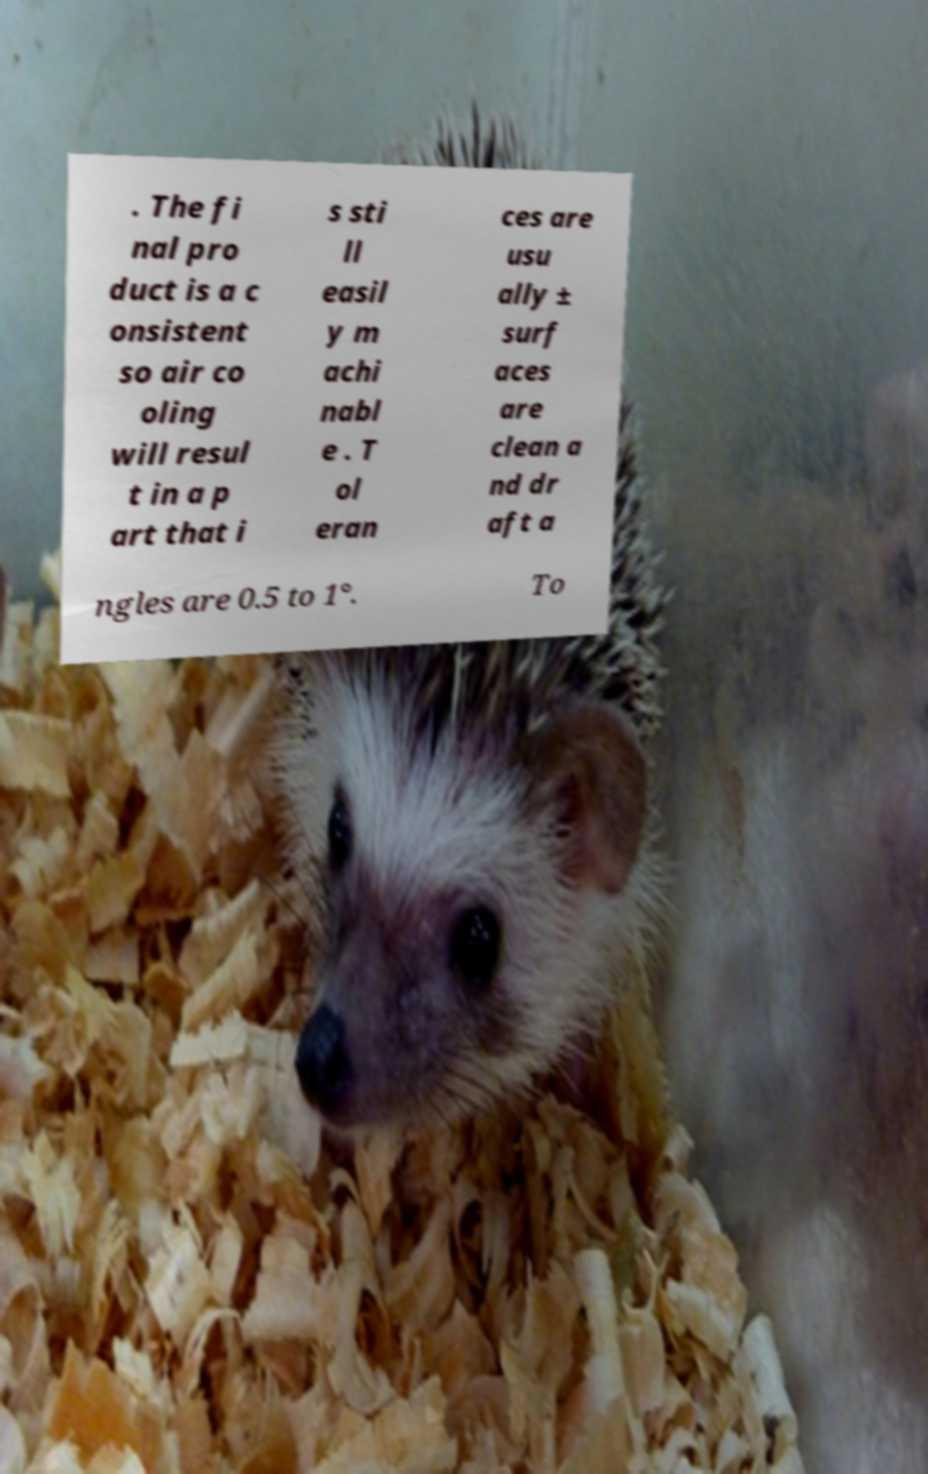Please read and relay the text visible in this image. What does it say? . The fi nal pro duct is a c onsistent so air co oling will resul t in a p art that i s sti ll easil y m achi nabl e . T ol eran ces are usu ally ± surf aces are clean a nd dr aft a ngles are 0.5 to 1°. To 